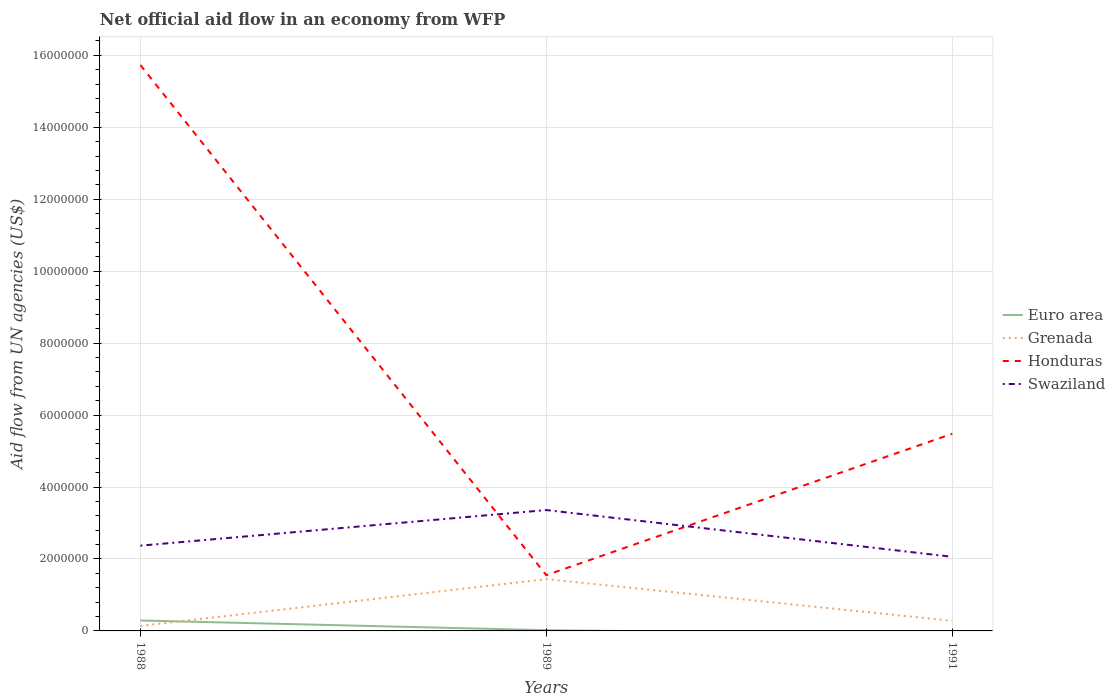Does the line corresponding to Grenada intersect with the line corresponding to Honduras?
Keep it short and to the point. No. Is the number of lines equal to the number of legend labels?
Your answer should be very brief. No. What is the total net official aid flow in Grenada in the graph?
Ensure brevity in your answer.  1.16e+06. What is the difference between the highest and the second highest net official aid flow in Swaziland?
Your answer should be compact. 1.30e+06. What is the difference between the highest and the lowest net official aid flow in Honduras?
Your answer should be compact. 1. How many lines are there?
Make the answer very short. 4. How many years are there in the graph?
Provide a short and direct response. 3. How are the legend labels stacked?
Your response must be concise. Vertical. What is the title of the graph?
Offer a terse response. Net official aid flow in an economy from WFP. Does "Chile" appear as one of the legend labels in the graph?
Ensure brevity in your answer.  No. What is the label or title of the X-axis?
Your answer should be very brief. Years. What is the label or title of the Y-axis?
Offer a terse response. Aid flow from UN agencies (US$). What is the Aid flow from UN agencies (US$) of Euro area in 1988?
Your response must be concise. 2.90e+05. What is the Aid flow from UN agencies (US$) in Grenada in 1988?
Your answer should be very brief. 1.40e+05. What is the Aid flow from UN agencies (US$) in Honduras in 1988?
Keep it short and to the point. 1.57e+07. What is the Aid flow from UN agencies (US$) in Swaziland in 1988?
Offer a very short reply. 2.37e+06. What is the Aid flow from UN agencies (US$) in Euro area in 1989?
Provide a succinct answer. 2.00e+04. What is the Aid flow from UN agencies (US$) in Grenada in 1989?
Offer a very short reply. 1.44e+06. What is the Aid flow from UN agencies (US$) in Honduras in 1989?
Keep it short and to the point. 1.55e+06. What is the Aid flow from UN agencies (US$) of Swaziland in 1989?
Provide a short and direct response. 3.36e+06. What is the Aid flow from UN agencies (US$) in Euro area in 1991?
Give a very brief answer. 0. What is the Aid flow from UN agencies (US$) in Honduras in 1991?
Offer a very short reply. 5.48e+06. What is the Aid flow from UN agencies (US$) in Swaziland in 1991?
Keep it short and to the point. 2.06e+06. Across all years, what is the maximum Aid flow from UN agencies (US$) of Grenada?
Make the answer very short. 1.44e+06. Across all years, what is the maximum Aid flow from UN agencies (US$) in Honduras?
Offer a terse response. 1.57e+07. Across all years, what is the maximum Aid flow from UN agencies (US$) in Swaziland?
Offer a terse response. 3.36e+06. Across all years, what is the minimum Aid flow from UN agencies (US$) of Euro area?
Your answer should be compact. 0. Across all years, what is the minimum Aid flow from UN agencies (US$) in Grenada?
Make the answer very short. 1.40e+05. Across all years, what is the minimum Aid flow from UN agencies (US$) in Honduras?
Provide a short and direct response. 1.55e+06. Across all years, what is the minimum Aid flow from UN agencies (US$) of Swaziland?
Give a very brief answer. 2.06e+06. What is the total Aid flow from UN agencies (US$) in Euro area in the graph?
Your response must be concise. 3.10e+05. What is the total Aid flow from UN agencies (US$) in Grenada in the graph?
Your answer should be compact. 1.86e+06. What is the total Aid flow from UN agencies (US$) of Honduras in the graph?
Ensure brevity in your answer.  2.28e+07. What is the total Aid flow from UN agencies (US$) of Swaziland in the graph?
Provide a short and direct response. 7.79e+06. What is the difference between the Aid flow from UN agencies (US$) of Euro area in 1988 and that in 1989?
Ensure brevity in your answer.  2.70e+05. What is the difference between the Aid flow from UN agencies (US$) in Grenada in 1988 and that in 1989?
Provide a short and direct response. -1.30e+06. What is the difference between the Aid flow from UN agencies (US$) in Honduras in 1988 and that in 1989?
Ensure brevity in your answer.  1.42e+07. What is the difference between the Aid flow from UN agencies (US$) in Swaziland in 1988 and that in 1989?
Provide a succinct answer. -9.90e+05. What is the difference between the Aid flow from UN agencies (US$) of Grenada in 1988 and that in 1991?
Provide a short and direct response. -1.40e+05. What is the difference between the Aid flow from UN agencies (US$) of Honduras in 1988 and that in 1991?
Make the answer very short. 1.02e+07. What is the difference between the Aid flow from UN agencies (US$) in Grenada in 1989 and that in 1991?
Give a very brief answer. 1.16e+06. What is the difference between the Aid flow from UN agencies (US$) in Honduras in 1989 and that in 1991?
Ensure brevity in your answer.  -3.93e+06. What is the difference between the Aid flow from UN agencies (US$) of Swaziland in 1989 and that in 1991?
Your answer should be compact. 1.30e+06. What is the difference between the Aid flow from UN agencies (US$) of Euro area in 1988 and the Aid flow from UN agencies (US$) of Grenada in 1989?
Ensure brevity in your answer.  -1.15e+06. What is the difference between the Aid flow from UN agencies (US$) of Euro area in 1988 and the Aid flow from UN agencies (US$) of Honduras in 1989?
Your answer should be compact. -1.26e+06. What is the difference between the Aid flow from UN agencies (US$) in Euro area in 1988 and the Aid flow from UN agencies (US$) in Swaziland in 1989?
Ensure brevity in your answer.  -3.07e+06. What is the difference between the Aid flow from UN agencies (US$) of Grenada in 1988 and the Aid flow from UN agencies (US$) of Honduras in 1989?
Keep it short and to the point. -1.41e+06. What is the difference between the Aid flow from UN agencies (US$) in Grenada in 1988 and the Aid flow from UN agencies (US$) in Swaziland in 1989?
Your answer should be very brief. -3.22e+06. What is the difference between the Aid flow from UN agencies (US$) of Honduras in 1988 and the Aid flow from UN agencies (US$) of Swaziland in 1989?
Give a very brief answer. 1.24e+07. What is the difference between the Aid flow from UN agencies (US$) of Euro area in 1988 and the Aid flow from UN agencies (US$) of Grenada in 1991?
Your response must be concise. 10000. What is the difference between the Aid flow from UN agencies (US$) in Euro area in 1988 and the Aid flow from UN agencies (US$) in Honduras in 1991?
Offer a terse response. -5.19e+06. What is the difference between the Aid flow from UN agencies (US$) of Euro area in 1988 and the Aid flow from UN agencies (US$) of Swaziland in 1991?
Your answer should be compact. -1.77e+06. What is the difference between the Aid flow from UN agencies (US$) of Grenada in 1988 and the Aid flow from UN agencies (US$) of Honduras in 1991?
Your answer should be compact. -5.34e+06. What is the difference between the Aid flow from UN agencies (US$) in Grenada in 1988 and the Aid flow from UN agencies (US$) in Swaziland in 1991?
Offer a terse response. -1.92e+06. What is the difference between the Aid flow from UN agencies (US$) of Honduras in 1988 and the Aid flow from UN agencies (US$) of Swaziland in 1991?
Offer a very short reply. 1.37e+07. What is the difference between the Aid flow from UN agencies (US$) of Euro area in 1989 and the Aid flow from UN agencies (US$) of Grenada in 1991?
Give a very brief answer. -2.60e+05. What is the difference between the Aid flow from UN agencies (US$) in Euro area in 1989 and the Aid flow from UN agencies (US$) in Honduras in 1991?
Provide a short and direct response. -5.46e+06. What is the difference between the Aid flow from UN agencies (US$) in Euro area in 1989 and the Aid flow from UN agencies (US$) in Swaziland in 1991?
Your answer should be compact. -2.04e+06. What is the difference between the Aid flow from UN agencies (US$) in Grenada in 1989 and the Aid flow from UN agencies (US$) in Honduras in 1991?
Make the answer very short. -4.04e+06. What is the difference between the Aid flow from UN agencies (US$) of Grenada in 1989 and the Aid flow from UN agencies (US$) of Swaziland in 1991?
Give a very brief answer. -6.20e+05. What is the difference between the Aid flow from UN agencies (US$) of Honduras in 1989 and the Aid flow from UN agencies (US$) of Swaziland in 1991?
Provide a short and direct response. -5.10e+05. What is the average Aid flow from UN agencies (US$) of Euro area per year?
Your answer should be compact. 1.03e+05. What is the average Aid flow from UN agencies (US$) of Grenada per year?
Offer a terse response. 6.20e+05. What is the average Aid flow from UN agencies (US$) of Honduras per year?
Your answer should be very brief. 7.59e+06. What is the average Aid flow from UN agencies (US$) in Swaziland per year?
Your answer should be compact. 2.60e+06. In the year 1988, what is the difference between the Aid flow from UN agencies (US$) of Euro area and Aid flow from UN agencies (US$) of Grenada?
Ensure brevity in your answer.  1.50e+05. In the year 1988, what is the difference between the Aid flow from UN agencies (US$) in Euro area and Aid flow from UN agencies (US$) in Honduras?
Provide a short and direct response. -1.54e+07. In the year 1988, what is the difference between the Aid flow from UN agencies (US$) in Euro area and Aid flow from UN agencies (US$) in Swaziland?
Offer a very short reply. -2.08e+06. In the year 1988, what is the difference between the Aid flow from UN agencies (US$) of Grenada and Aid flow from UN agencies (US$) of Honduras?
Provide a short and direct response. -1.56e+07. In the year 1988, what is the difference between the Aid flow from UN agencies (US$) in Grenada and Aid flow from UN agencies (US$) in Swaziland?
Your answer should be compact. -2.23e+06. In the year 1988, what is the difference between the Aid flow from UN agencies (US$) of Honduras and Aid flow from UN agencies (US$) of Swaziland?
Keep it short and to the point. 1.34e+07. In the year 1989, what is the difference between the Aid flow from UN agencies (US$) of Euro area and Aid flow from UN agencies (US$) of Grenada?
Your answer should be very brief. -1.42e+06. In the year 1989, what is the difference between the Aid flow from UN agencies (US$) of Euro area and Aid flow from UN agencies (US$) of Honduras?
Provide a succinct answer. -1.53e+06. In the year 1989, what is the difference between the Aid flow from UN agencies (US$) in Euro area and Aid flow from UN agencies (US$) in Swaziland?
Offer a very short reply. -3.34e+06. In the year 1989, what is the difference between the Aid flow from UN agencies (US$) in Grenada and Aid flow from UN agencies (US$) in Swaziland?
Keep it short and to the point. -1.92e+06. In the year 1989, what is the difference between the Aid flow from UN agencies (US$) in Honduras and Aid flow from UN agencies (US$) in Swaziland?
Offer a terse response. -1.81e+06. In the year 1991, what is the difference between the Aid flow from UN agencies (US$) in Grenada and Aid flow from UN agencies (US$) in Honduras?
Give a very brief answer. -5.20e+06. In the year 1991, what is the difference between the Aid flow from UN agencies (US$) of Grenada and Aid flow from UN agencies (US$) of Swaziland?
Make the answer very short. -1.78e+06. In the year 1991, what is the difference between the Aid flow from UN agencies (US$) in Honduras and Aid flow from UN agencies (US$) in Swaziland?
Provide a short and direct response. 3.42e+06. What is the ratio of the Aid flow from UN agencies (US$) of Euro area in 1988 to that in 1989?
Ensure brevity in your answer.  14.5. What is the ratio of the Aid flow from UN agencies (US$) in Grenada in 1988 to that in 1989?
Provide a succinct answer. 0.1. What is the ratio of the Aid flow from UN agencies (US$) of Honduras in 1988 to that in 1989?
Provide a short and direct response. 10.15. What is the ratio of the Aid flow from UN agencies (US$) in Swaziland in 1988 to that in 1989?
Offer a very short reply. 0.71. What is the ratio of the Aid flow from UN agencies (US$) of Grenada in 1988 to that in 1991?
Offer a very short reply. 0.5. What is the ratio of the Aid flow from UN agencies (US$) of Honduras in 1988 to that in 1991?
Your answer should be compact. 2.87. What is the ratio of the Aid flow from UN agencies (US$) of Swaziland in 1988 to that in 1991?
Provide a succinct answer. 1.15. What is the ratio of the Aid flow from UN agencies (US$) in Grenada in 1989 to that in 1991?
Your response must be concise. 5.14. What is the ratio of the Aid flow from UN agencies (US$) of Honduras in 1989 to that in 1991?
Your response must be concise. 0.28. What is the ratio of the Aid flow from UN agencies (US$) in Swaziland in 1989 to that in 1991?
Give a very brief answer. 1.63. What is the difference between the highest and the second highest Aid flow from UN agencies (US$) in Grenada?
Ensure brevity in your answer.  1.16e+06. What is the difference between the highest and the second highest Aid flow from UN agencies (US$) of Honduras?
Offer a very short reply. 1.02e+07. What is the difference between the highest and the second highest Aid flow from UN agencies (US$) of Swaziland?
Give a very brief answer. 9.90e+05. What is the difference between the highest and the lowest Aid flow from UN agencies (US$) in Grenada?
Keep it short and to the point. 1.30e+06. What is the difference between the highest and the lowest Aid flow from UN agencies (US$) of Honduras?
Provide a short and direct response. 1.42e+07. What is the difference between the highest and the lowest Aid flow from UN agencies (US$) in Swaziland?
Offer a very short reply. 1.30e+06. 